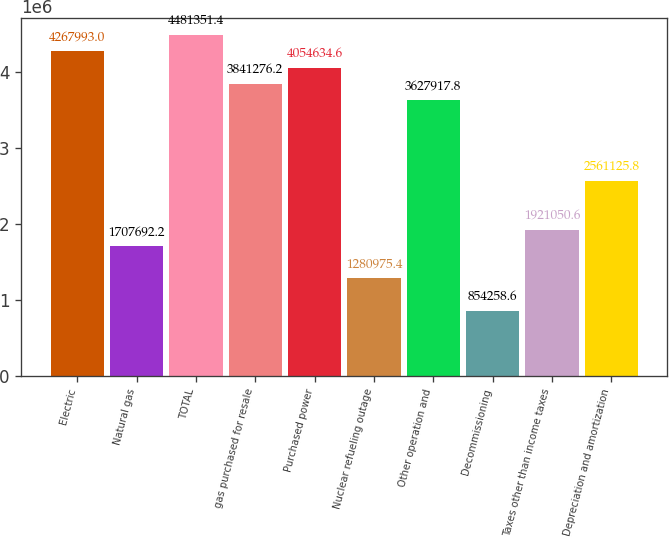<chart> <loc_0><loc_0><loc_500><loc_500><bar_chart><fcel>Electric<fcel>Natural gas<fcel>TOTAL<fcel>gas purchased for resale<fcel>Purchased power<fcel>Nuclear refueling outage<fcel>Other operation and<fcel>Decommissioning<fcel>Taxes other than income taxes<fcel>Depreciation and amortization<nl><fcel>4.26799e+06<fcel>1.70769e+06<fcel>4.48135e+06<fcel>3.84128e+06<fcel>4.05463e+06<fcel>1.28098e+06<fcel>3.62792e+06<fcel>854259<fcel>1.92105e+06<fcel>2.56113e+06<nl></chart> 